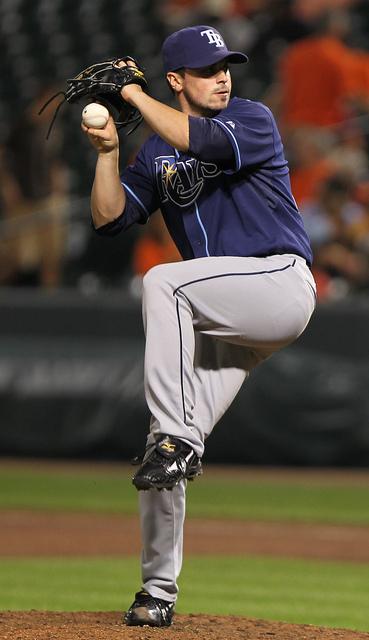What finger is not inside the pitcher's glove?
Answer briefly. Thumb. What position is this man playing?
Give a very brief answer. Pitcher. Is his uniform striped?
Answer briefly. No. Is this man prepared to hit the ball?
Answer briefly. No. What color is the baseball bat?
Quick response, please. Blue. What is he holding?
Keep it brief. Ball. What team is the man playing for?
Keep it brief. Rays. What game is the playing?
Be succinct. Baseball. 